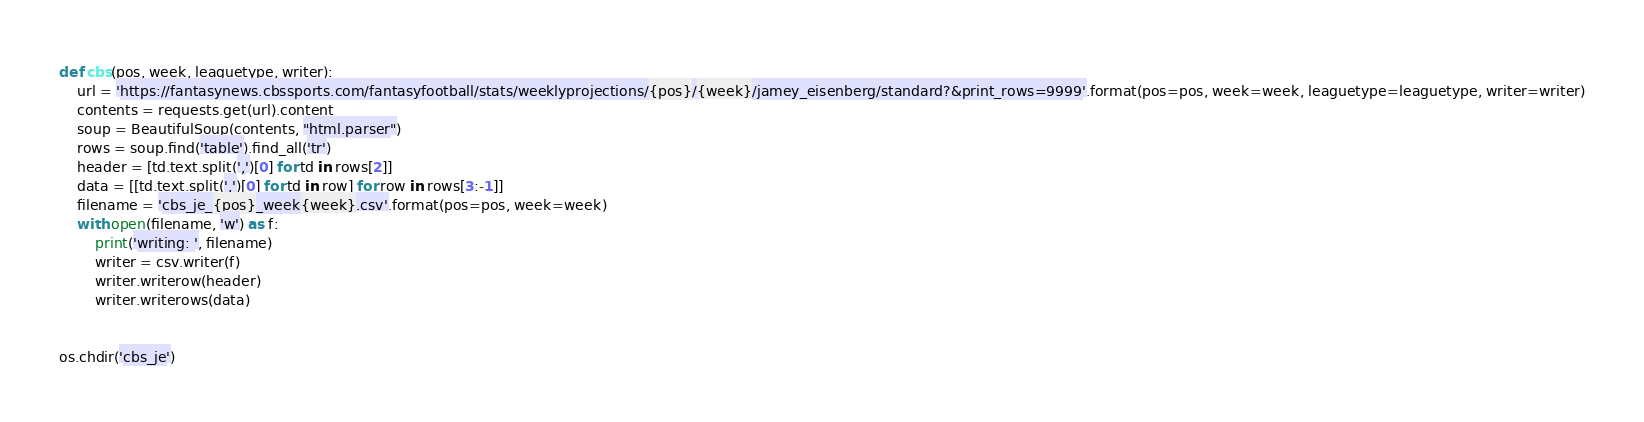Convert code to text. <code><loc_0><loc_0><loc_500><loc_500><_Python_>def cbs(pos, week, leaguetype, writer):
    url = 'https://fantasynews.cbssports.com/fantasyfootball/stats/weeklyprojections/{pos}/{week}/jamey_eisenberg/standard?&print_rows=9999'.format(pos=pos, week=week, leaguetype=leaguetype, writer=writer)
    contents = requests.get(url).content
    soup = BeautifulSoup(contents, "html.parser")
    rows = soup.find('table').find_all('tr')
    header = [td.text.split(',')[0] for td in rows[2]]
    data = [[td.text.split(',')[0] for td in row] for row in rows[3:-1]]
    filename = 'cbs_je_{pos}_week{week}.csv'.format(pos=pos, week=week)
    with open(filename, 'w') as f:
        print('writing: ', filename)
        writer = csv.writer(f)
        writer.writerow(header)
        writer.writerows(data)


os.chdir('cbs_je')</code> 